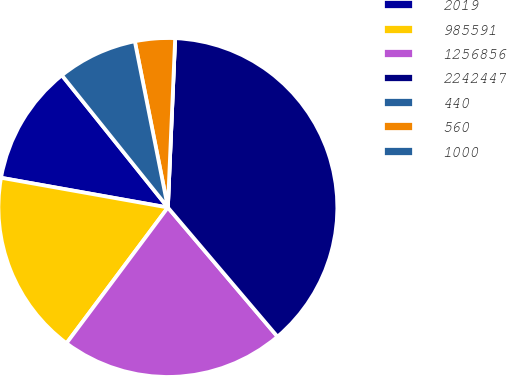Convert chart to OTSL. <chart><loc_0><loc_0><loc_500><loc_500><pie_chart><fcel>2019<fcel>985591<fcel>1256856<fcel>2242447<fcel>440<fcel>560<fcel>1000<nl><fcel>11.44%<fcel>17.6%<fcel>21.41%<fcel>38.12%<fcel>0.0%<fcel>3.81%<fcel>7.63%<nl></chart> 